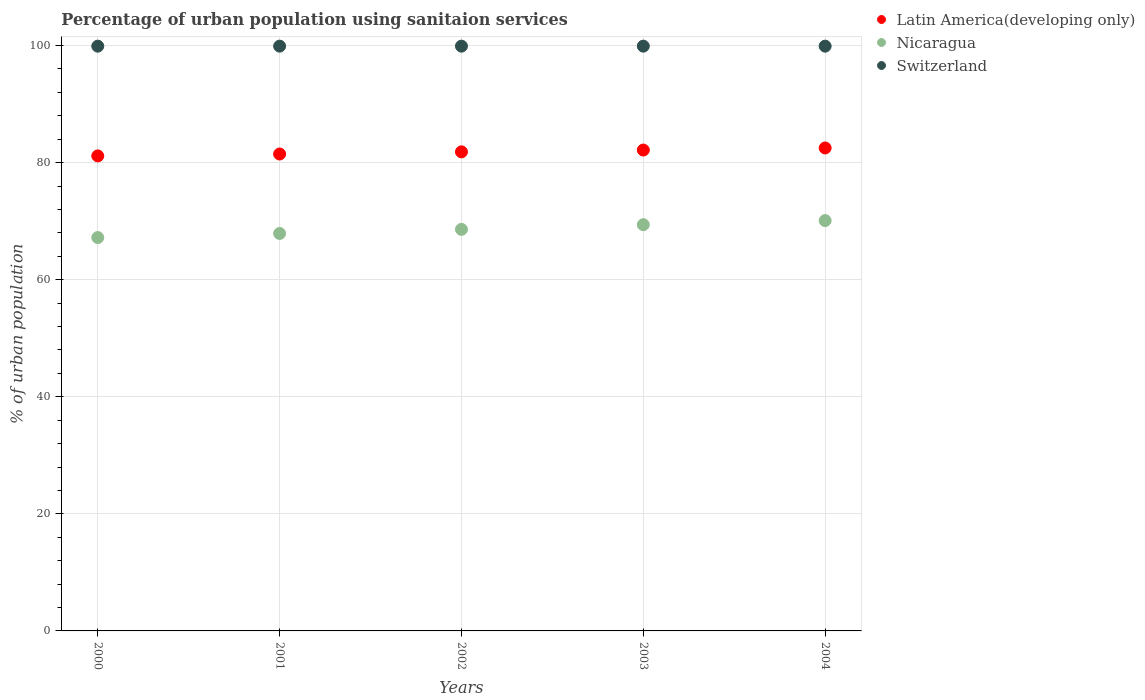Is the number of dotlines equal to the number of legend labels?
Provide a short and direct response. Yes. What is the percentage of urban population using sanitaion services in Latin America(developing only) in 2003?
Make the answer very short. 82.15. Across all years, what is the maximum percentage of urban population using sanitaion services in Switzerland?
Provide a succinct answer. 99.9. Across all years, what is the minimum percentage of urban population using sanitaion services in Nicaragua?
Ensure brevity in your answer.  67.2. What is the total percentage of urban population using sanitaion services in Switzerland in the graph?
Your answer should be very brief. 499.5. What is the difference between the percentage of urban population using sanitaion services in Switzerland in 2003 and the percentage of urban population using sanitaion services in Latin America(developing only) in 2000?
Provide a short and direct response. 18.75. What is the average percentage of urban population using sanitaion services in Nicaragua per year?
Offer a very short reply. 68.64. In the year 2000, what is the difference between the percentage of urban population using sanitaion services in Nicaragua and percentage of urban population using sanitaion services in Latin America(developing only)?
Provide a short and direct response. -13.95. What is the ratio of the percentage of urban population using sanitaion services in Switzerland in 2000 to that in 2001?
Provide a short and direct response. 1. Is the percentage of urban population using sanitaion services in Nicaragua in 2002 less than that in 2004?
Provide a succinct answer. Yes. What is the difference between the highest and the second highest percentage of urban population using sanitaion services in Latin America(developing only)?
Offer a terse response. 0.36. What is the difference between the highest and the lowest percentage of urban population using sanitaion services in Switzerland?
Provide a succinct answer. 0. Is the percentage of urban population using sanitaion services in Switzerland strictly greater than the percentage of urban population using sanitaion services in Nicaragua over the years?
Provide a succinct answer. Yes. How many dotlines are there?
Make the answer very short. 3. How many years are there in the graph?
Your answer should be compact. 5. Does the graph contain grids?
Give a very brief answer. Yes. Where does the legend appear in the graph?
Provide a short and direct response. Top right. How are the legend labels stacked?
Give a very brief answer. Vertical. What is the title of the graph?
Keep it short and to the point. Percentage of urban population using sanitaion services. What is the label or title of the X-axis?
Provide a short and direct response. Years. What is the label or title of the Y-axis?
Give a very brief answer. % of urban population. What is the % of urban population in Latin America(developing only) in 2000?
Offer a very short reply. 81.15. What is the % of urban population in Nicaragua in 2000?
Your answer should be very brief. 67.2. What is the % of urban population in Switzerland in 2000?
Make the answer very short. 99.9. What is the % of urban population in Latin America(developing only) in 2001?
Your answer should be very brief. 81.47. What is the % of urban population in Nicaragua in 2001?
Ensure brevity in your answer.  67.9. What is the % of urban population in Switzerland in 2001?
Keep it short and to the point. 99.9. What is the % of urban population in Latin America(developing only) in 2002?
Your answer should be compact. 81.84. What is the % of urban population in Nicaragua in 2002?
Make the answer very short. 68.6. What is the % of urban population of Switzerland in 2002?
Offer a very short reply. 99.9. What is the % of urban population of Latin America(developing only) in 2003?
Keep it short and to the point. 82.15. What is the % of urban population of Nicaragua in 2003?
Give a very brief answer. 69.4. What is the % of urban population of Switzerland in 2003?
Your response must be concise. 99.9. What is the % of urban population of Latin America(developing only) in 2004?
Offer a very short reply. 82.51. What is the % of urban population of Nicaragua in 2004?
Keep it short and to the point. 70.1. What is the % of urban population in Switzerland in 2004?
Offer a terse response. 99.9. Across all years, what is the maximum % of urban population in Latin America(developing only)?
Your answer should be compact. 82.51. Across all years, what is the maximum % of urban population in Nicaragua?
Give a very brief answer. 70.1. Across all years, what is the maximum % of urban population of Switzerland?
Make the answer very short. 99.9. Across all years, what is the minimum % of urban population in Latin America(developing only)?
Your answer should be compact. 81.15. Across all years, what is the minimum % of urban population in Nicaragua?
Your response must be concise. 67.2. Across all years, what is the minimum % of urban population of Switzerland?
Give a very brief answer. 99.9. What is the total % of urban population in Latin America(developing only) in the graph?
Your response must be concise. 409.12. What is the total % of urban population of Nicaragua in the graph?
Keep it short and to the point. 343.2. What is the total % of urban population in Switzerland in the graph?
Provide a succinct answer. 499.5. What is the difference between the % of urban population in Latin America(developing only) in 2000 and that in 2001?
Offer a very short reply. -0.32. What is the difference between the % of urban population in Nicaragua in 2000 and that in 2001?
Offer a very short reply. -0.7. What is the difference between the % of urban population in Latin America(developing only) in 2000 and that in 2002?
Make the answer very short. -0.69. What is the difference between the % of urban population in Switzerland in 2000 and that in 2002?
Offer a terse response. 0. What is the difference between the % of urban population in Latin America(developing only) in 2000 and that in 2003?
Your response must be concise. -1. What is the difference between the % of urban population of Nicaragua in 2000 and that in 2003?
Keep it short and to the point. -2.2. What is the difference between the % of urban population in Latin America(developing only) in 2000 and that in 2004?
Your answer should be compact. -1.35. What is the difference between the % of urban population of Nicaragua in 2000 and that in 2004?
Your answer should be very brief. -2.9. What is the difference between the % of urban population of Switzerland in 2000 and that in 2004?
Your response must be concise. 0. What is the difference between the % of urban population of Latin America(developing only) in 2001 and that in 2002?
Make the answer very short. -0.37. What is the difference between the % of urban population of Latin America(developing only) in 2001 and that in 2003?
Provide a succinct answer. -0.68. What is the difference between the % of urban population in Switzerland in 2001 and that in 2003?
Your answer should be compact. 0. What is the difference between the % of urban population in Latin America(developing only) in 2001 and that in 2004?
Provide a succinct answer. -1.03. What is the difference between the % of urban population in Switzerland in 2001 and that in 2004?
Your answer should be very brief. 0. What is the difference between the % of urban population of Latin America(developing only) in 2002 and that in 2003?
Ensure brevity in your answer.  -0.31. What is the difference between the % of urban population of Latin America(developing only) in 2002 and that in 2004?
Your answer should be very brief. -0.66. What is the difference between the % of urban population in Switzerland in 2002 and that in 2004?
Your response must be concise. 0. What is the difference between the % of urban population in Latin America(developing only) in 2003 and that in 2004?
Keep it short and to the point. -0.36. What is the difference between the % of urban population in Nicaragua in 2003 and that in 2004?
Make the answer very short. -0.7. What is the difference between the % of urban population in Switzerland in 2003 and that in 2004?
Your response must be concise. 0. What is the difference between the % of urban population of Latin America(developing only) in 2000 and the % of urban population of Nicaragua in 2001?
Your answer should be very brief. 13.25. What is the difference between the % of urban population of Latin America(developing only) in 2000 and the % of urban population of Switzerland in 2001?
Your answer should be compact. -18.75. What is the difference between the % of urban population in Nicaragua in 2000 and the % of urban population in Switzerland in 2001?
Your response must be concise. -32.7. What is the difference between the % of urban population in Latin America(developing only) in 2000 and the % of urban population in Nicaragua in 2002?
Provide a succinct answer. 12.55. What is the difference between the % of urban population in Latin America(developing only) in 2000 and the % of urban population in Switzerland in 2002?
Your response must be concise. -18.75. What is the difference between the % of urban population in Nicaragua in 2000 and the % of urban population in Switzerland in 2002?
Offer a terse response. -32.7. What is the difference between the % of urban population in Latin America(developing only) in 2000 and the % of urban population in Nicaragua in 2003?
Ensure brevity in your answer.  11.75. What is the difference between the % of urban population in Latin America(developing only) in 2000 and the % of urban population in Switzerland in 2003?
Provide a succinct answer. -18.75. What is the difference between the % of urban population of Nicaragua in 2000 and the % of urban population of Switzerland in 2003?
Offer a very short reply. -32.7. What is the difference between the % of urban population of Latin America(developing only) in 2000 and the % of urban population of Nicaragua in 2004?
Provide a succinct answer. 11.05. What is the difference between the % of urban population of Latin America(developing only) in 2000 and the % of urban population of Switzerland in 2004?
Keep it short and to the point. -18.75. What is the difference between the % of urban population of Nicaragua in 2000 and the % of urban population of Switzerland in 2004?
Give a very brief answer. -32.7. What is the difference between the % of urban population of Latin America(developing only) in 2001 and the % of urban population of Nicaragua in 2002?
Offer a terse response. 12.87. What is the difference between the % of urban population in Latin America(developing only) in 2001 and the % of urban population in Switzerland in 2002?
Offer a terse response. -18.43. What is the difference between the % of urban population in Nicaragua in 2001 and the % of urban population in Switzerland in 2002?
Your answer should be very brief. -32. What is the difference between the % of urban population in Latin America(developing only) in 2001 and the % of urban population in Nicaragua in 2003?
Provide a succinct answer. 12.07. What is the difference between the % of urban population of Latin America(developing only) in 2001 and the % of urban population of Switzerland in 2003?
Your answer should be compact. -18.43. What is the difference between the % of urban population in Nicaragua in 2001 and the % of urban population in Switzerland in 2003?
Offer a terse response. -32. What is the difference between the % of urban population in Latin America(developing only) in 2001 and the % of urban population in Nicaragua in 2004?
Give a very brief answer. 11.37. What is the difference between the % of urban population in Latin America(developing only) in 2001 and the % of urban population in Switzerland in 2004?
Your answer should be compact. -18.43. What is the difference between the % of urban population in Nicaragua in 2001 and the % of urban population in Switzerland in 2004?
Ensure brevity in your answer.  -32. What is the difference between the % of urban population in Latin America(developing only) in 2002 and the % of urban population in Nicaragua in 2003?
Provide a succinct answer. 12.44. What is the difference between the % of urban population in Latin America(developing only) in 2002 and the % of urban population in Switzerland in 2003?
Provide a short and direct response. -18.06. What is the difference between the % of urban population in Nicaragua in 2002 and the % of urban population in Switzerland in 2003?
Make the answer very short. -31.3. What is the difference between the % of urban population in Latin America(developing only) in 2002 and the % of urban population in Nicaragua in 2004?
Offer a very short reply. 11.74. What is the difference between the % of urban population of Latin America(developing only) in 2002 and the % of urban population of Switzerland in 2004?
Provide a succinct answer. -18.06. What is the difference between the % of urban population of Nicaragua in 2002 and the % of urban population of Switzerland in 2004?
Your answer should be compact. -31.3. What is the difference between the % of urban population in Latin America(developing only) in 2003 and the % of urban population in Nicaragua in 2004?
Provide a short and direct response. 12.05. What is the difference between the % of urban population in Latin America(developing only) in 2003 and the % of urban population in Switzerland in 2004?
Keep it short and to the point. -17.75. What is the difference between the % of urban population in Nicaragua in 2003 and the % of urban population in Switzerland in 2004?
Give a very brief answer. -30.5. What is the average % of urban population in Latin America(developing only) per year?
Give a very brief answer. 81.82. What is the average % of urban population of Nicaragua per year?
Make the answer very short. 68.64. What is the average % of urban population in Switzerland per year?
Your answer should be very brief. 99.9. In the year 2000, what is the difference between the % of urban population of Latin America(developing only) and % of urban population of Nicaragua?
Make the answer very short. 13.95. In the year 2000, what is the difference between the % of urban population in Latin America(developing only) and % of urban population in Switzerland?
Your answer should be very brief. -18.75. In the year 2000, what is the difference between the % of urban population in Nicaragua and % of urban population in Switzerland?
Offer a very short reply. -32.7. In the year 2001, what is the difference between the % of urban population in Latin America(developing only) and % of urban population in Nicaragua?
Offer a terse response. 13.57. In the year 2001, what is the difference between the % of urban population in Latin America(developing only) and % of urban population in Switzerland?
Provide a short and direct response. -18.43. In the year 2001, what is the difference between the % of urban population in Nicaragua and % of urban population in Switzerland?
Your answer should be compact. -32. In the year 2002, what is the difference between the % of urban population of Latin America(developing only) and % of urban population of Nicaragua?
Ensure brevity in your answer.  13.24. In the year 2002, what is the difference between the % of urban population of Latin America(developing only) and % of urban population of Switzerland?
Give a very brief answer. -18.06. In the year 2002, what is the difference between the % of urban population in Nicaragua and % of urban population in Switzerland?
Provide a succinct answer. -31.3. In the year 2003, what is the difference between the % of urban population of Latin America(developing only) and % of urban population of Nicaragua?
Offer a terse response. 12.75. In the year 2003, what is the difference between the % of urban population of Latin America(developing only) and % of urban population of Switzerland?
Your answer should be compact. -17.75. In the year 2003, what is the difference between the % of urban population in Nicaragua and % of urban population in Switzerland?
Offer a very short reply. -30.5. In the year 2004, what is the difference between the % of urban population of Latin America(developing only) and % of urban population of Nicaragua?
Provide a succinct answer. 12.41. In the year 2004, what is the difference between the % of urban population of Latin America(developing only) and % of urban population of Switzerland?
Your response must be concise. -17.39. In the year 2004, what is the difference between the % of urban population in Nicaragua and % of urban population in Switzerland?
Offer a very short reply. -29.8. What is the ratio of the % of urban population in Latin America(developing only) in 2000 to that in 2001?
Make the answer very short. 1. What is the ratio of the % of urban population in Nicaragua in 2000 to that in 2001?
Your answer should be compact. 0.99. What is the ratio of the % of urban population of Latin America(developing only) in 2000 to that in 2002?
Give a very brief answer. 0.99. What is the ratio of the % of urban population of Nicaragua in 2000 to that in 2002?
Keep it short and to the point. 0.98. What is the ratio of the % of urban population of Latin America(developing only) in 2000 to that in 2003?
Provide a succinct answer. 0.99. What is the ratio of the % of urban population of Nicaragua in 2000 to that in 2003?
Ensure brevity in your answer.  0.97. What is the ratio of the % of urban population of Latin America(developing only) in 2000 to that in 2004?
Your answer should be very brief. 0.98. What is the ratio of the % of urban population of Nicaragua in 2000 to that in 2004?
Your answer should be very brief. 0.96. What is the ratio of the % of urban population of Switzerland in 2000 to that in 2004?
Your answer should be very brief. 1. What is the ratio of the % of urban population of Nicaragua in 2001 to that in 2003?
Ensure brevity in your answer.  0.98. What is the ratio of the % of urban population of Latin America(developing only) in 2001 to that in 2004?
Offer a very short reply. 0.99. What is the ratio of the % of urban population of Nicaragua in 2001 to that in 2004?
Your answer should be very brief. 0.97. What is the ratio of the % of urban population in Switzerland in 2001 to that in 2004?
Your answer should be very brief. 1. What is the ratio of the % of urban population in Latin America(developing only) in 2002 to that in 2003?
Your answer should be compact. 1. What is the ratio of the % of urban population of Latin America(developing only) in 2002 to that in 2004?
Offer a very short reply. 0.99. What is the ratio of the % of urban population of Nicaragua in 2002 to that in 2004?
Your answer should be very brief. 0.98. What is the ratio of the % of urban population of Switzerland in 2002 to that in 2004?
Provide a succinct answer. 1. What is the ratio of the % of urban population in Switzerland in 2003 to that in 2004?
Your answer should be compact. 1. What is the difference between the highest and the second highest % of urban population in Latin America(developing only)?
Your answer should be very brief. 0.36. What is the difference between the highest and the second highest % of urban population in Nicaragua?
Your answer should be compact. 0.7. What is the difference between the highest and the second highest % of urban population in Switzerland?
Your response must be concise. 0. What is the difference between the highest and the lowest % of urban population of Latin America(developing only)?
Make the answer very short. 1.35. What is the difference between the highest and the lowest % of urban population in Nicaragua?
Make the answer very short. 2.9. What is the difference between the highest and the lowest % of urban population of Switzerland?
Provide a succinct answer. 0. 